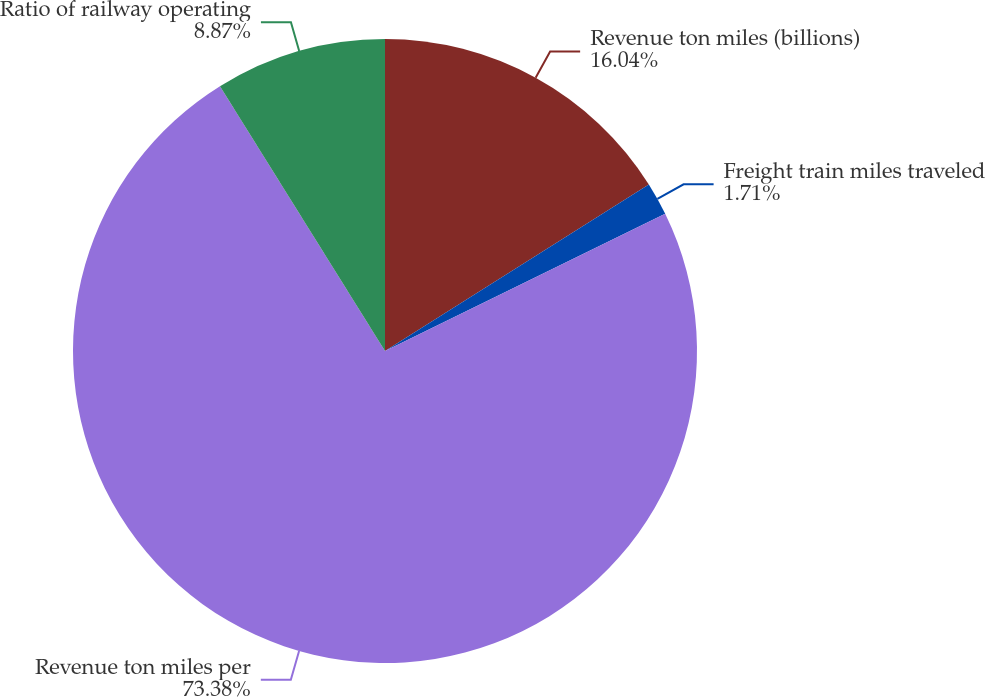Convert chart. <chart><loc_0><loc_0><loc_500><loc_500><pie_chart><fcel>Revenue ton miles (billions)<fcel>Freight train miles traveled<fcel>Revenue ton miles per<fcel>Ratio of railway operating<nl><fcel>16.04%<fcel>1.71%<fcel>73.38%<fcel>8.87%<nl></chart> 